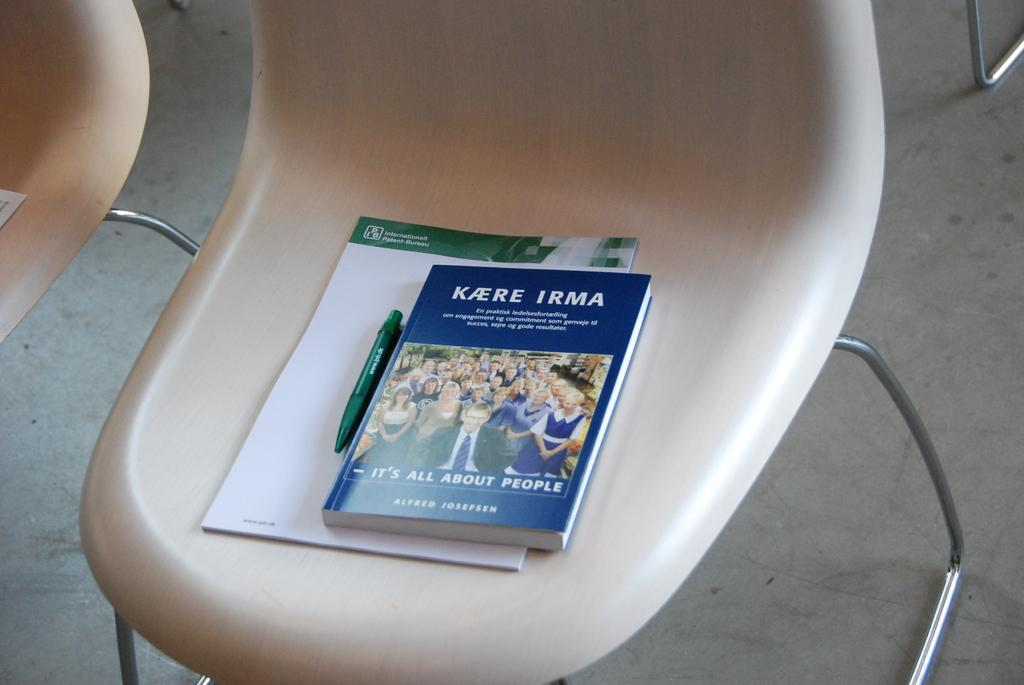<image>
Render a clear and concise summary of the photo. A blue and white book 'its all about people' by Kaere Irma with a green ball point pen and a writing pad on a beige chair 